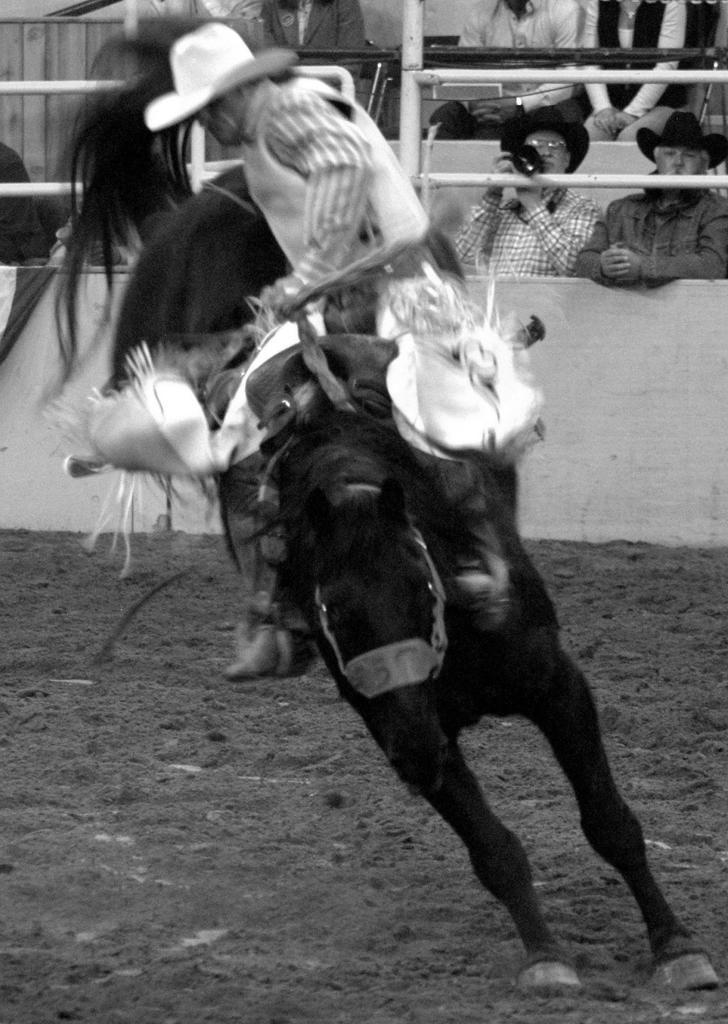Could you give a brief overview of what you see in this image? In this picture there are group of persons. In the front a man is riding a horse on the ground wearing a hat. In the background there are two persons wearing a black colour hat. The in the center man is holding a camera in his hand. In the background there are three person sitting. 